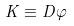<formula> <loc_0><loc_0><loc_500><loc_500>K \equiv D \varphi</formula> 